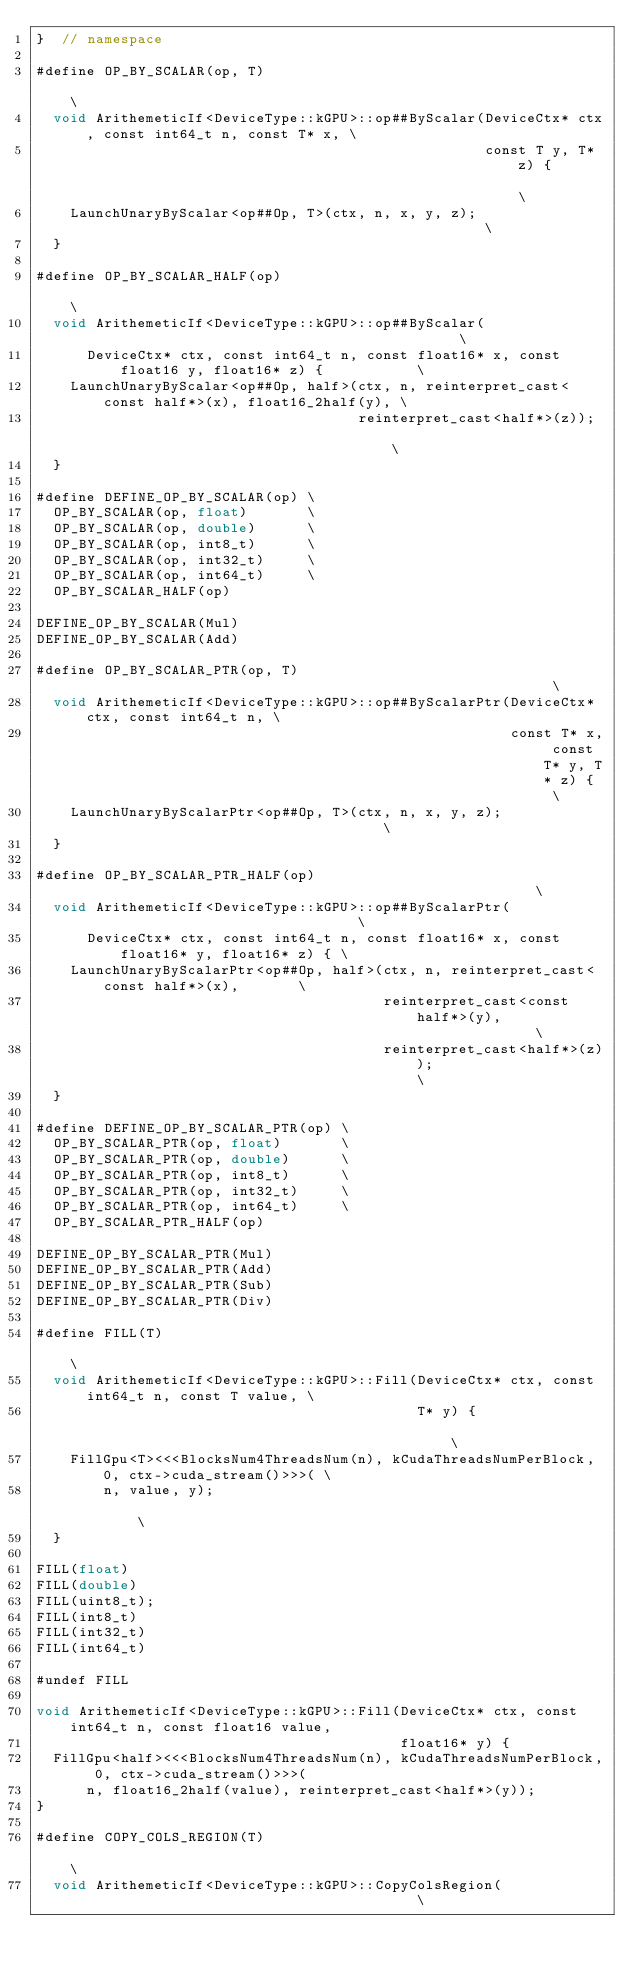Convert code to text. <code><loc_0><loc_0><loc_500><loc_500><_Cuda_>}  // namespace

#define OP_BY_SCALAR(op, T)                                                                       \
  void ArithemeticIf<DeviceType::kGPU>::op##ByScalar(DeviceCtx* ctx, const int64_t n, const T* x, \
                                                     const T y, T* z) {                           \
    LaunchUnaryByScalar<op##Op, T>(ctx, n, x, y, z);                                              \
  }

#define OP_BY_SCALAR_HALF(op)                                                                     \
  void ArithemeticIf<DeviceType::kGPU>::op##ByScalar(                                             \
      DeviceCtx* ctx, const int64_t n, const float16* x, const float16 y, float16* z) {           \
    LaunchUnaryByScalar<op##Op, half>(ctx, n, reinterpret_cast<const half*>(x), float16_2half(y), \
                                      reinterpret_cast<half*>(z));                                \
  }

#define DEFINE_OP_BY_SCALAR(op) \
  OP_BY_SCALAR(op, float)       \
  OP_BY_SCALAR(op, double)      \
  OP_BY_SCALAR(op, int8_t)      \
  OP_BY_SCALAR(op, int32_t)     \
  OP_BY_SCALAR(op, int64_t)     \
  OP_BY_SCALAR_HALF(op)

DEFINE_OP_BY_SCALAR(Mul)
DEFINE_OP_BY_SCALAR(Add)

#define OP_BY_SCALAR_PTR(op, T)                                                          \
  void ArithemeticIf<DeviceType::kGPU>::op##ByScalarPtr(DeviceCtx* ctx, const int64_t n, \
                                                        const T* x, const T* y, T* z) {  \
    LaunchUnaryByScalarPtr<op##Op, T>(ctx, n, x, y, z);                                  \
  }

#define OP_BY_SCALAR_PTR_HALF(op)                                                        \
  void ArithemeticIf<DeviceType::kGPU>::op##ByScalarPtr(                                 \
      DeviceCtx* ctx, const int64_t n, const float16* x, const float16* y, float16* z) { \
    LaunchUnaryByScalarPtr<op##Op, half>(ctx, n, reinterpret_cast<const half*>(x),       \
                                         reinterpret_cast<const half*>(y),               \
                                         reinterpret_cast<half*>(z));                    \
  }

#define DEFINE_OP_BY_SCALAR_PTR(op) \
  OP_BY_SCALAR_PTR(op, float)       \
  OP_BY_SCALAR_PTR(op, double)      \
  OP_BY_SCALAR_PTR(op, int8_t)      \
  OP_BY_SCALAR_PTR(op, int32_t)     \
  OP_BY_SCALAR_PTR(op, int64_t)     \
  OP_BY_SCALAR_PTR_HALF(op)

DEFINE_OP_BY_SCALAR_PTR(Mul)
DEFINE_OP_BY_SCALAR_PTR(Add)
DEFINE_OP_BY_SCALAR_PTR(Sub)
DEFINE_OP_BY_SCALAR_PTR(Div)

#define FILL(T)                                                                              \
  void ArithemeticIf<DeviceType::kGPU>::Fill(DeviceCtx* ctx, const int64_t n, const T value, \
                                             T* y) {                                         \
    FillGpu<T><<<BlocksNum4ThreadsNum(n), kCudaThreadsNumPerBlock, 0, ctx->cuda_stream()>>>( \
        n, value, y);                                                                        \
  }

FILL(float)
FILL(double)
FILL(uint8_t);
FILL(int8_t)
FILL(int32_t)
FILL(int64_t)

#undef FILL

void ArithemeticIf<DeviceType::kGPU>::Fill(DeviceCtx* ctx, const int64_t n, const float16 value,
                                           float16* y) {
  FillGpu<half><<<BlocksNum4ThreadsNum(n), kCudaThreadsNumPerBlock, 0, ctx->cuda_stream()>>>(
      n, float16_2half(value), reinterpret_cast<half*>(y));
}

#define COPY_COLS_REGION(T)                                                                    \
  void ArithemeticIf<DeviceType::kGPU>::CopyColsRegion(                                        \</code> 